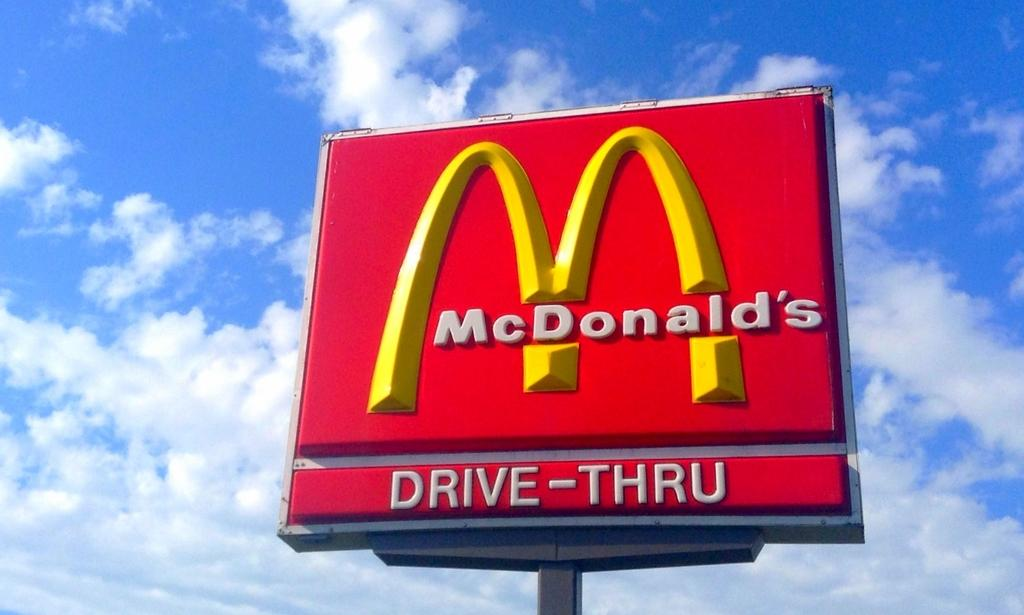<image>
Write a terse but informative summary of the picture. A McDonald's sign indicates that the restaurant has a Drive-Thru. 